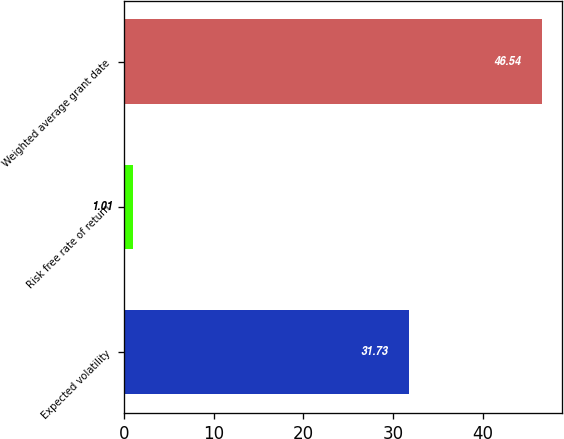Convert chart to OTSL. <chart><loc_0><loc_0><loc_500><loc_500><bar_chart><fcel>Expected volatility<fcel>Risk free rate of return<fcel>Weighted average grant date<nl><fcel>31.73<fcel>1.01<fcel>46.54<nl></chart> 